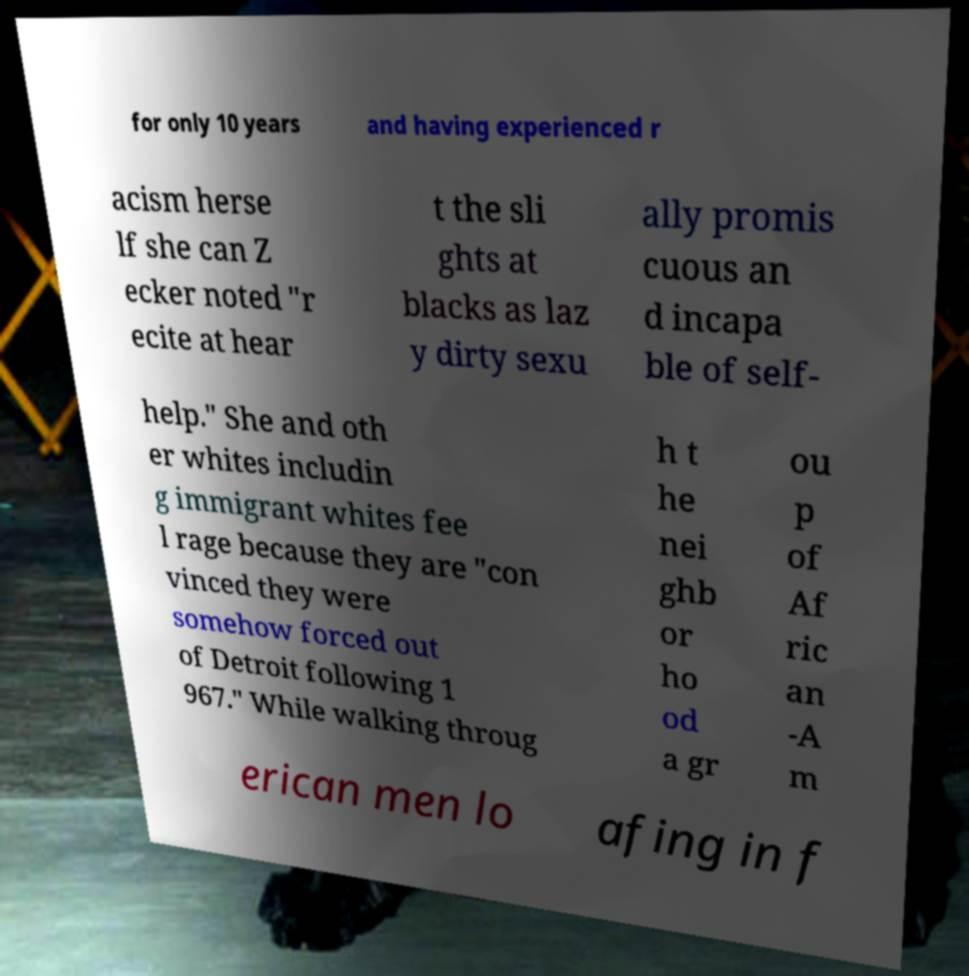Please identify and transcribe the text found in this image. for only 10 years and having experienced r acism herse lf she can Z ecker noted "r ecite at hear t the sli ghts at blacks as laz y dirty sexu ally promis cuous an d incapa ble of self- help." She and oth er whites includin g immigrant whites fee l rage because they are "con vinced they were somehow forced out of Detroit following 1 967." While walking throug h t he nei ghb or ho od a gr ou p of Af ric an -A m erican men lo afing in f 